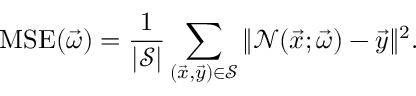Convert formula to latex. <formula><loc_0><loc_0><loc_500><loc_500>M S E ( \vec { \omega } ) = \frac { 1 } { | \mathcal { S } | } \sum _ { ( \vec { x } , \vec { y } ) \in \mathcal { S } } \| \mathcal { N } ( \vec { x } ; \vec { \omega } ) - \vec { y } \| ^ { 2 } .</formula> 